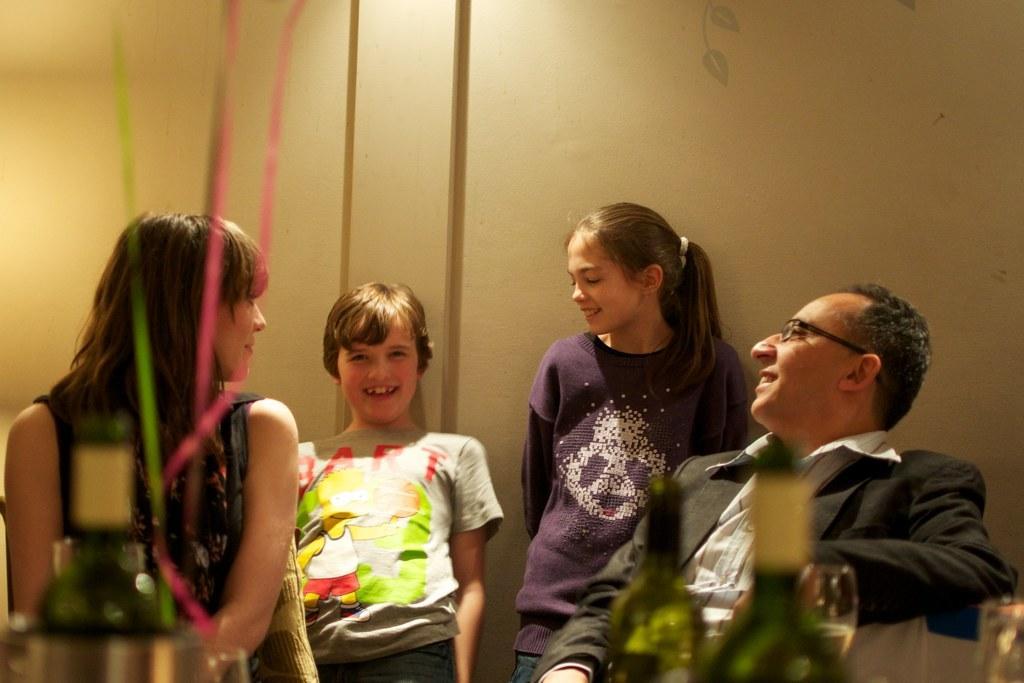Could you give a brief overview of what you see in this image? In this image there is a boy and a girl are standing. Right side there is a person wearing a blazer and spectacles. He is sitting. Left side there is a woman. Bottom of the image there are bottles and glasses. Background there is a wall. 